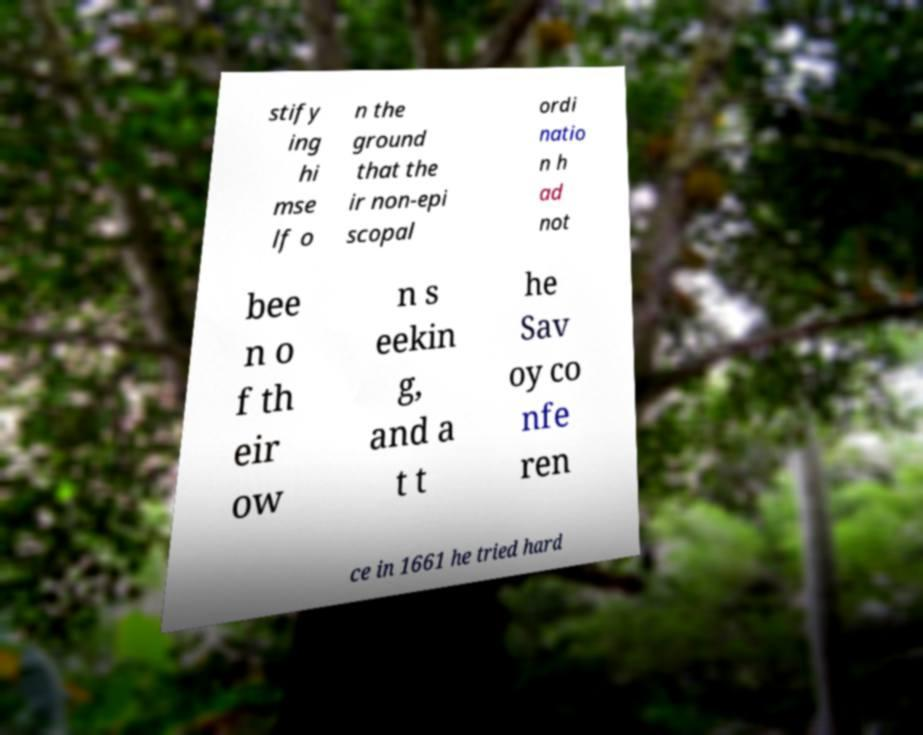There's text embedded in this image that I need extracted. Can you transcribe it verbatim? stify ing hi mse lf o n the ground that the ir non-epi scopal ordi natio n h ad not bee n o f th eir ow n s eekin g, and a t t he Sav oy co nfe ren ce in 1661 he tried hard 